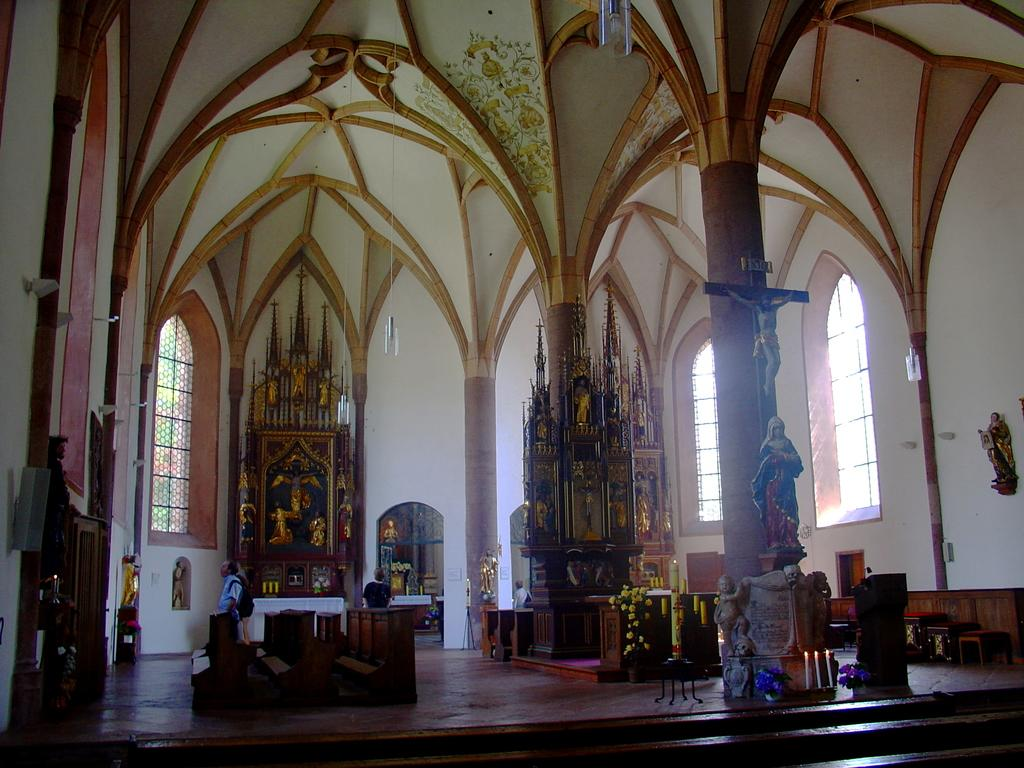What part of a building is shown in the image? The image shows the inner part of a building. What architectural feature can be seen in the image? There are windows visible in the image. What type of decorative objects are present in the image? There are statues in the image. What colors are used on the wall in the image? The wall has a white and brown color scheme. How many horses are visible in the image? There are no horses present in the image. What type of debt is being discussed in the image? There is no discussion of debt in the image; it features statues and a colorful wall. 